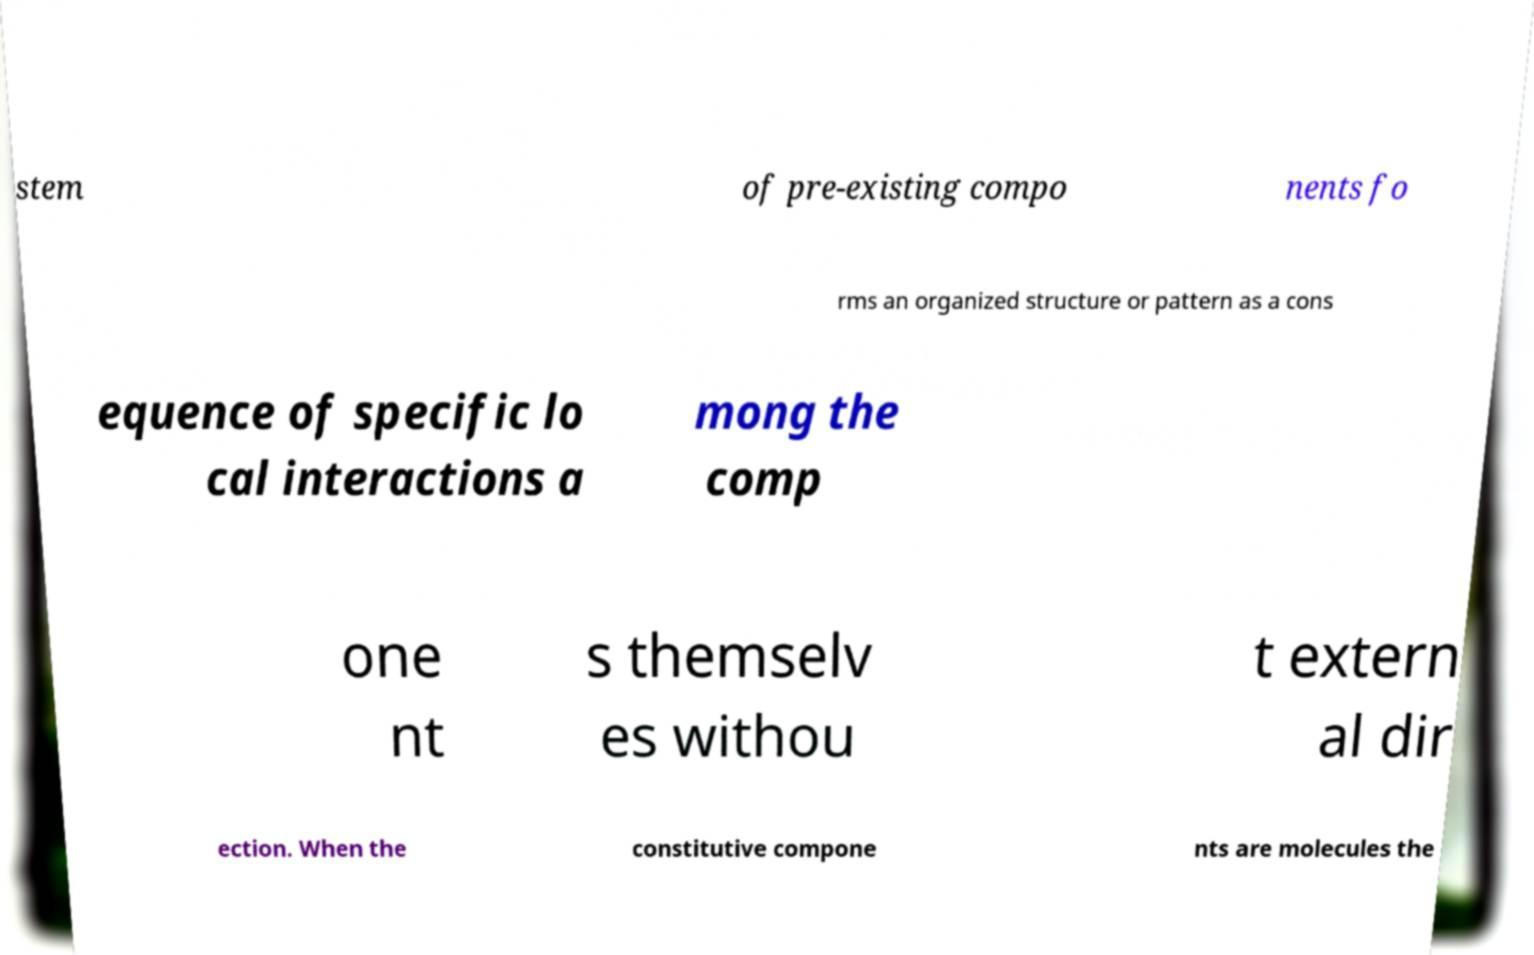Please identify and transcribe the text found in this image. stem of pre-existing compo nents fo rms an organized structure or pattern as a cons equence of specific lo cal interactions a mong the comp one nt s themselv es withou t extern al dir ection. When the constitutive compone nts are molecules the 